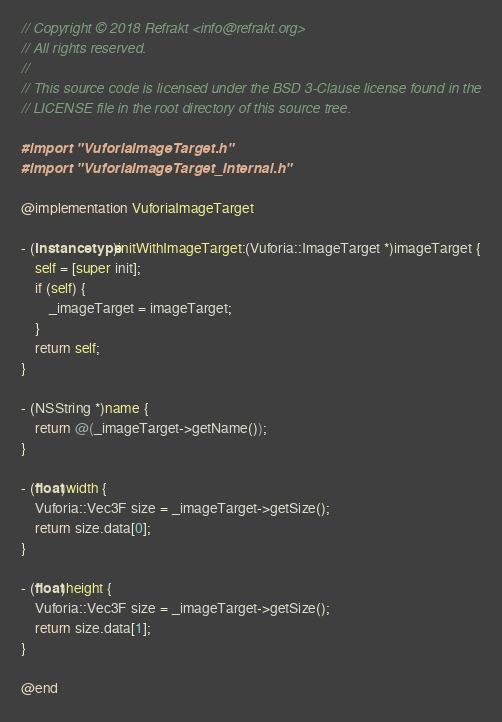<code> <loc_0><loc_0><loc_500><loc_500><_ObjectiveC_>// Copyright © 2018 Refrakt <info@refrakt.org>
// All rights reserved.
//
// This source code is licensed under the BSD 3-Clause license found in the
// LICENSE file in the root directory of this source tree.

#import "VuforiaImageTarget.h"
#import "VuforiaImageTarget_Internal.h"

@implementation VuforiaImageTarget

- (instancetype)initWithImageTarget:(Vuforia::ImageTarget *)imageTarget {
    self = [super init];
    if (self) {
        _imageTarget = imageTarget;
    }
    return self;
}

- (NSString *)name {
    return @(_imageTarget->getName());
}

- (float)width {
    Vuforia::Vec3F size = _imageTarget->getSize();
    return size.data[0];
}

- (float)height {
    Vuforia::Vec3F size = _imageTarget->getSize();
    return size.data[1];
}

@end
</code> 